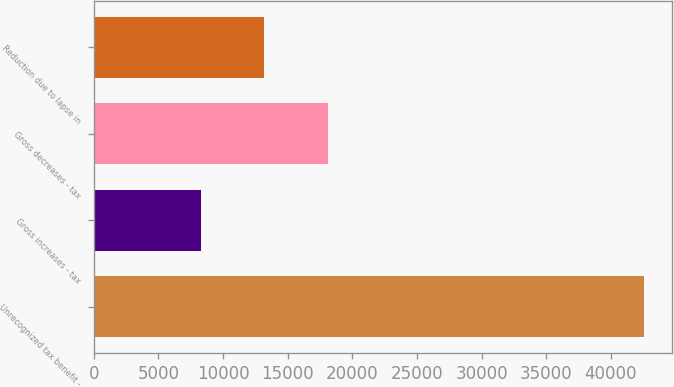Convert chart. <chart><loc_0><loc_0><loc_500><loc_500><bar_chart><fcel>Unrecognized tax benefit -<fcel>Gross increases - tax<fcel>Gross decreases - tax<fcel>Reduction due to lapse in<nl><fcel>42594<fcel>8305.5<fcel>18094.5<fcel>13200<nl></chart> 